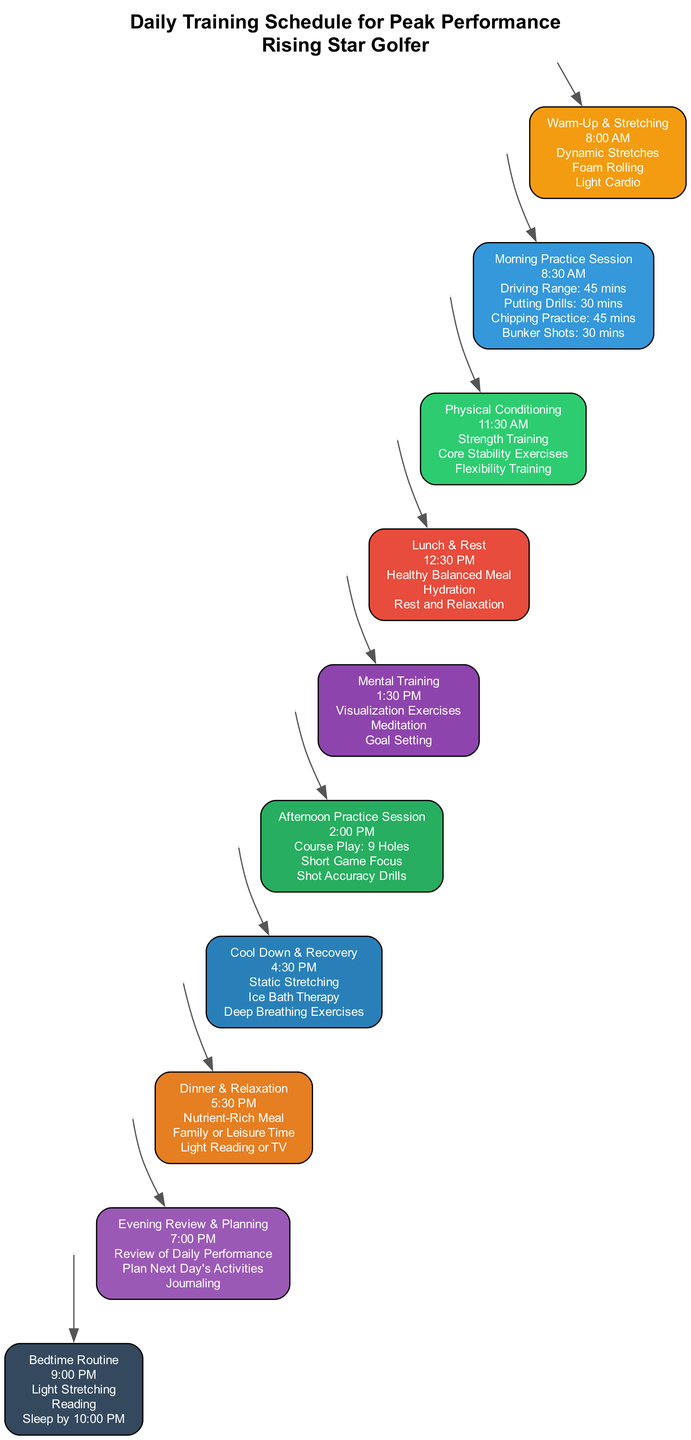What time does the Morning Practice Session start? The diagram states that the Morning Practice Session runs from 8:30 AM to 11:00 AM. Therefore, the start time is mentioned directly as 8:30 AM.
Answer: 8:30 AM How many activities are listed in the Physical Conditioning section? The Physical Conditioning section has three specific activities listed: Strength Training, Core Stability Exercises, and Flexibility Training. Thus, counting those activities gives us the total number.
Answer: 3 What color represents the Cool Down & Recovery period? The Cool Down & Recovery section is colored in a specific hex code, which is #2980B9 according to the diagram's breakdown of colors associated with each section.
Answer: #2980B9 Which session comes directly after Lunch & Rest? By looking at the sequence of activities in the diagram, the session that follows Lunch & Rest, which is from 12:30 PM to 1:30 PM, is the Mental Training session starting at 1:30 PM.
Answer: Mental Training What activities are included in the Evening Review & Planning? The Evening Review & Planning section includes three activities: Review of Daily Performance, Plan Next Day's Activities, and Journaling. Collectively, these represent all activities within that section.
Answer: Review of Daily Performance, Plan Next Day's Activities, Journaling How long is the Afternoon Practice Session? The Afternoon Practice Session starts at 2:00 PM and concludes at 4:30 PM, resulting in a duration of 2 hours and 30 minutes for that session.
Answer: 2 hours and 30 minutes What type of exercises are performed during the Mental Training period? The Mental Training section outlines three activities: Visualization Exercises, Meditation, and Goal Setting, which are focused on enhancing mental performance.
Answer: Visualization Exercises, Meditation, Goal Setting At what time does the Bedtime Routine begin? According to the timeline provided in the diagram, the Bedtime Routine begins at 9:00 PM sharp, which is explicitly stated in that section.
Answer: 9:00 PM How many major training sessions are there in total? Upon reviewing the entire training schedule from the diagram, there are a total of six major training sessions, counting each named section from Warm-Up & Stretching to Evening Review & Planning.
Answer: 6 